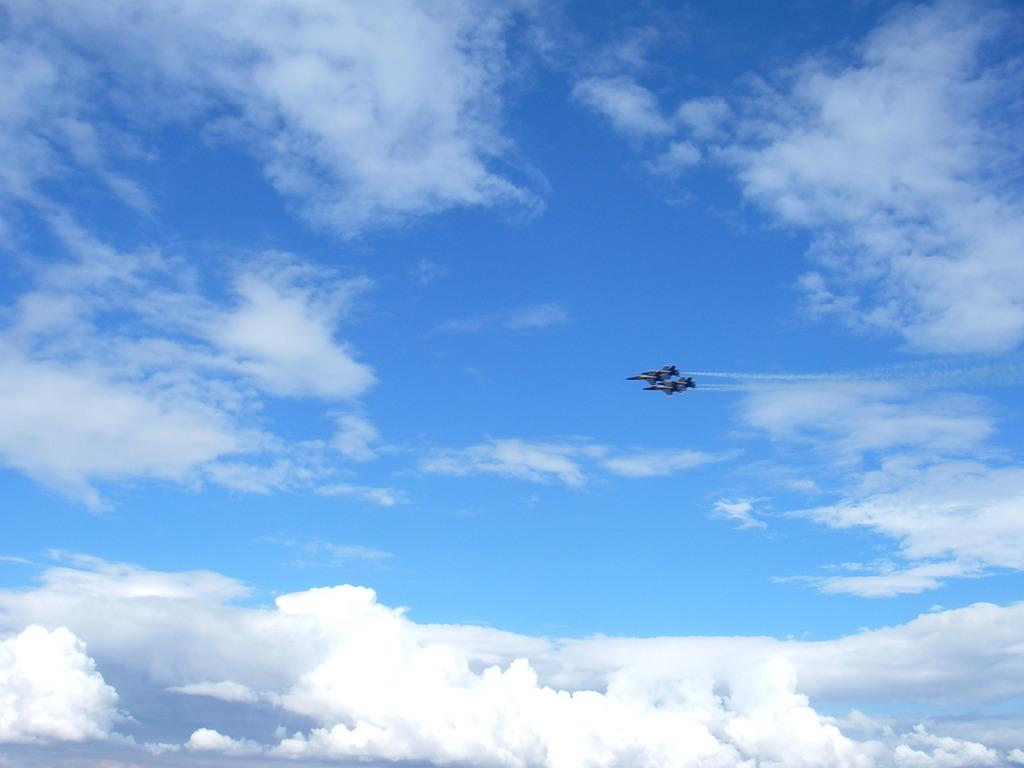What are the main subjects in the image? There are two planes in the image. What are the planes doing in the image? The planes are flying in the sky. What else can be seen in the sky in the image? There are clouds visible in the sky. What type of yam is being grown on the coast in the image? There is no yam or coast present in the image; it features two planes flying in the sky. What type of shame is being expressed by the planes in the image? There is no shame expressed by the planes in the image, as planes do not have emotions or the ability to express shame. 